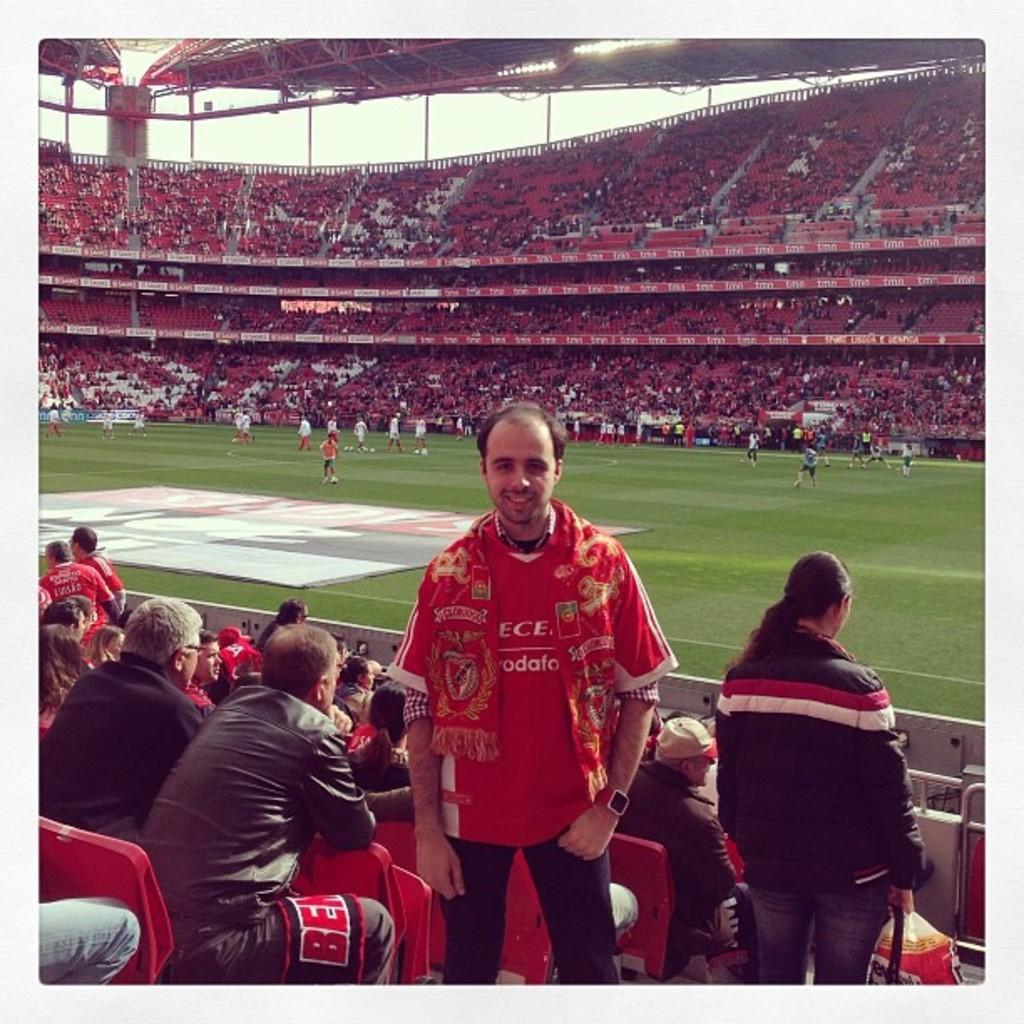Could you give a brief overview of what you see in this image? In this image I can see few people standing and few are sitting on the red color chairs. I can see few players in the ground. Top I can see poles and lights. 